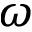Convert formula to latex. <formula><loc_0><loc_0><loc_500><loc_500>\omega</formula> 